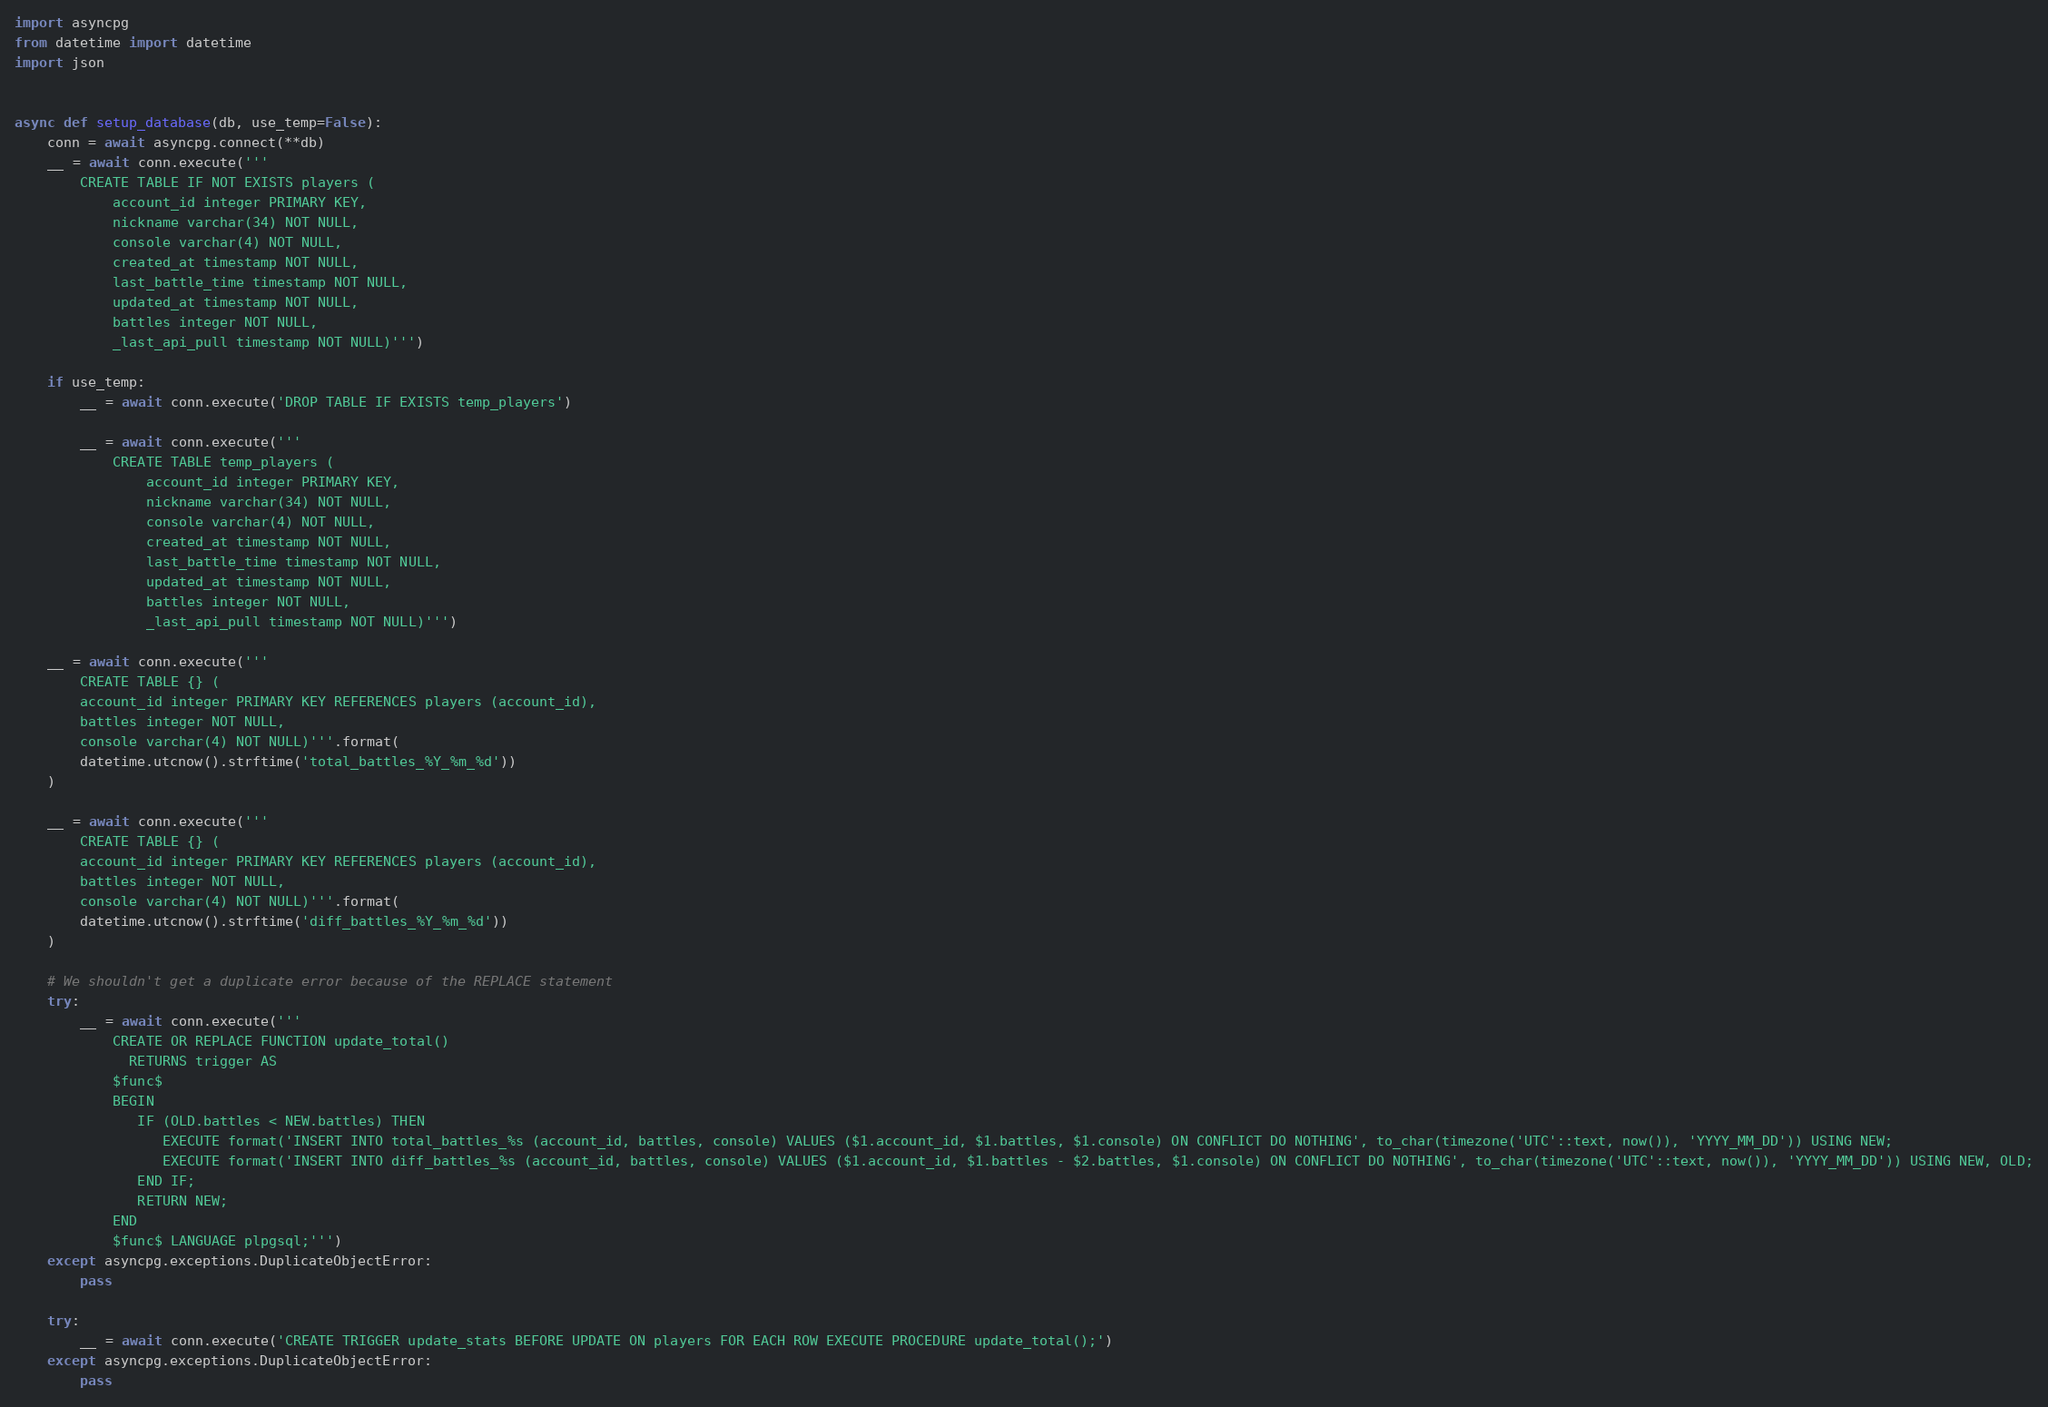<code> <loc_0><loc_0><loc_500><loc_500><_Python_>import asyncpg
from datetime import datetime
import json


async def setup_database(db, use_temp=False):
    conn = await asyncpg.connect(**db)
    __ = await conn.execute('''
        CREATE TABLE IF NOT EXISTS players (
            account_id integer PRIMARY KEY,
            nickname varchar(34) NOT NULL,
            console varchar(4) NOT NULL,
            created_at timestamp NOT NULL,
            last_battle_time timestamp NOT NULL,
            updated_at timestamp NOT NULL,
            battles integer NOT NULL,
            _last_api_pull timestamp NOT NULL)''')

    if use_temp:
        __ = await conn.execute('DROP TABLE IF EXISTS temp_players')

        __ = await conn.execute('''
            CREATE TABLE temp_players (
                account_id integer PRIMARY KEY,
                nickname varchar(34) NOT NULL,
                console varchar(4) NOT NULL,
                created_at timestamp NOT NULL,
                last_battle_time timestamp NOT NULL,
                updated_at timestamp NOT NULL,
                battles integer NOT NULL,
                _last_api_pull timestamp NOT NULL)''')

    __ = await conn.execute('''
        CREATE TABLE {} (
        account_id integer PRIMARY KEY REFERENCES players (account_id),
        battles integer NOT NULL,
        console varchar(4) NOT NULL)'''.format(
        datetime.utcnow().strftime('total_battles_%Y_%m_%d'))
    )

    __ = await conn.execute('''
        CREATE TABLE {} (
        account_id integer PRIMARY KEY REFERENCES players (account_id),
        battles integer NOT NULL,
        console varchar(4) NOT NULL)'''.format(
        datetime.utcnow().strftime('diff_battles_%Y_%m_%d'))
    )

    # We shouldn't get a duplicate error because of the REPLACE statement
    try:
        __ = await conn.execute('''
            CREATE OR REPLACE FUNCTION update_total()
              RETURNS trigger AS
            $func$
            BEGIN
               IF (OLD.battles < NEW.battles) THEN
                  EXECUTE format('INSERT INTO total_battles_%s (account_id, battles, console) VALUES ($1.account_id, $1.battles, $1.console) ON CONFLICT DO NOTHING', to_char(timezone('UTC'::text, now()), 'YYYY_MM_DD')) USING NEW;
                  EXECUTE format('INSERT INTO diff_battles_%s (account_id, battles, console) VALUES ($1.account_id, $1.battles - $2.battles, $1.console) ON CONFLICT DO NOTHING', to_char(timezone('UTC'::text, now()), 'YYYY_MM_DD')) USING NEW, OLD;
               END IF;
               RETURN NEW;
            END
            $func$ LANGUAGE plpgsql;''')
    except asyncpg.exceptions.DuplicateObjectError:
        pass

    try:
        __ = await conn.execute('CREATE TRIGGER update_stats BEFORE UPDATE ON players FOR EACH ROW EXECUTE PROCEDURE update_total();')
    except asyncpg.exceptions.DuplicateObjectError:
        pass
</code> 